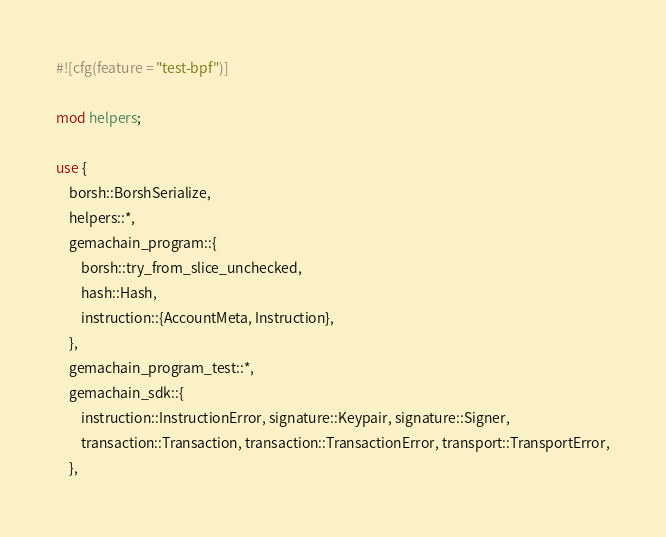<code> <loc_0><loc_0><loc_500><loc_500><_Rust_>#![cfg(feature = "test-bpf")]

mod helpers;

use {
    borsh::BorshSerialize,
    helpers::*,
    gemachain_program::{
        borsh::try_from_slice_unchecked,
        hash::Hash,
        instruction::{AccountMeta, Instruction},
    },
    gemachain_program_test::*,
    gemachain_sdk::{
        instruction::InstructionError, signature::Keypair, signature::Signer,
        transaction::Transaction, transaction::TransactionError, transport::TransportError,
    },</code> 